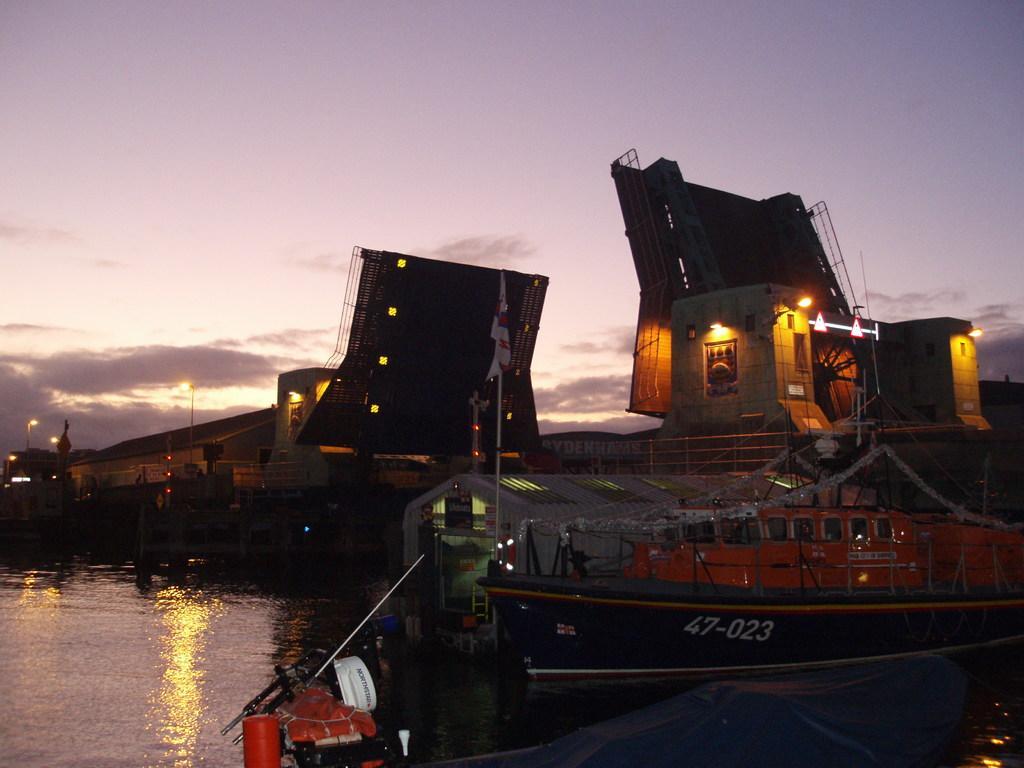Can you describe this image briefly? In this image, we can see boats and at the bottom, there is water. At the top, there is sky. 